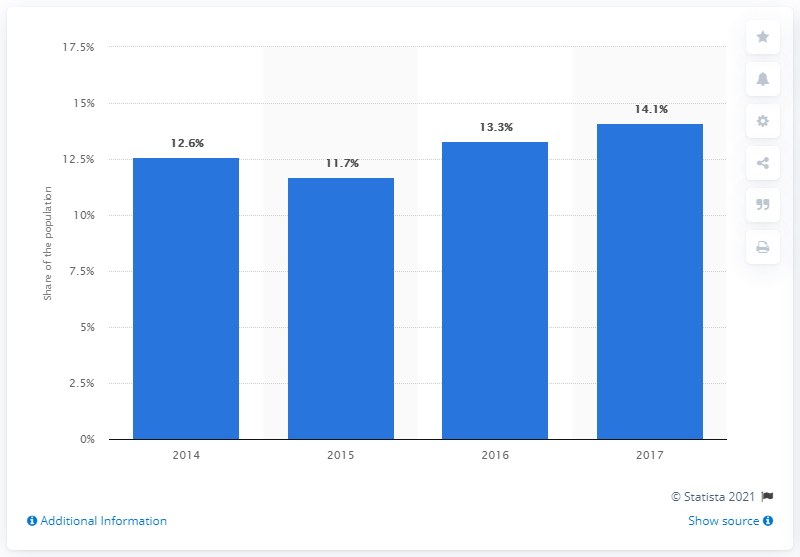Draw attention to some important aspects in this diagram. The unemployment rate in Curaao in 2015 was 11.7%. The unemployment rate in 2017 was 14.1%. 